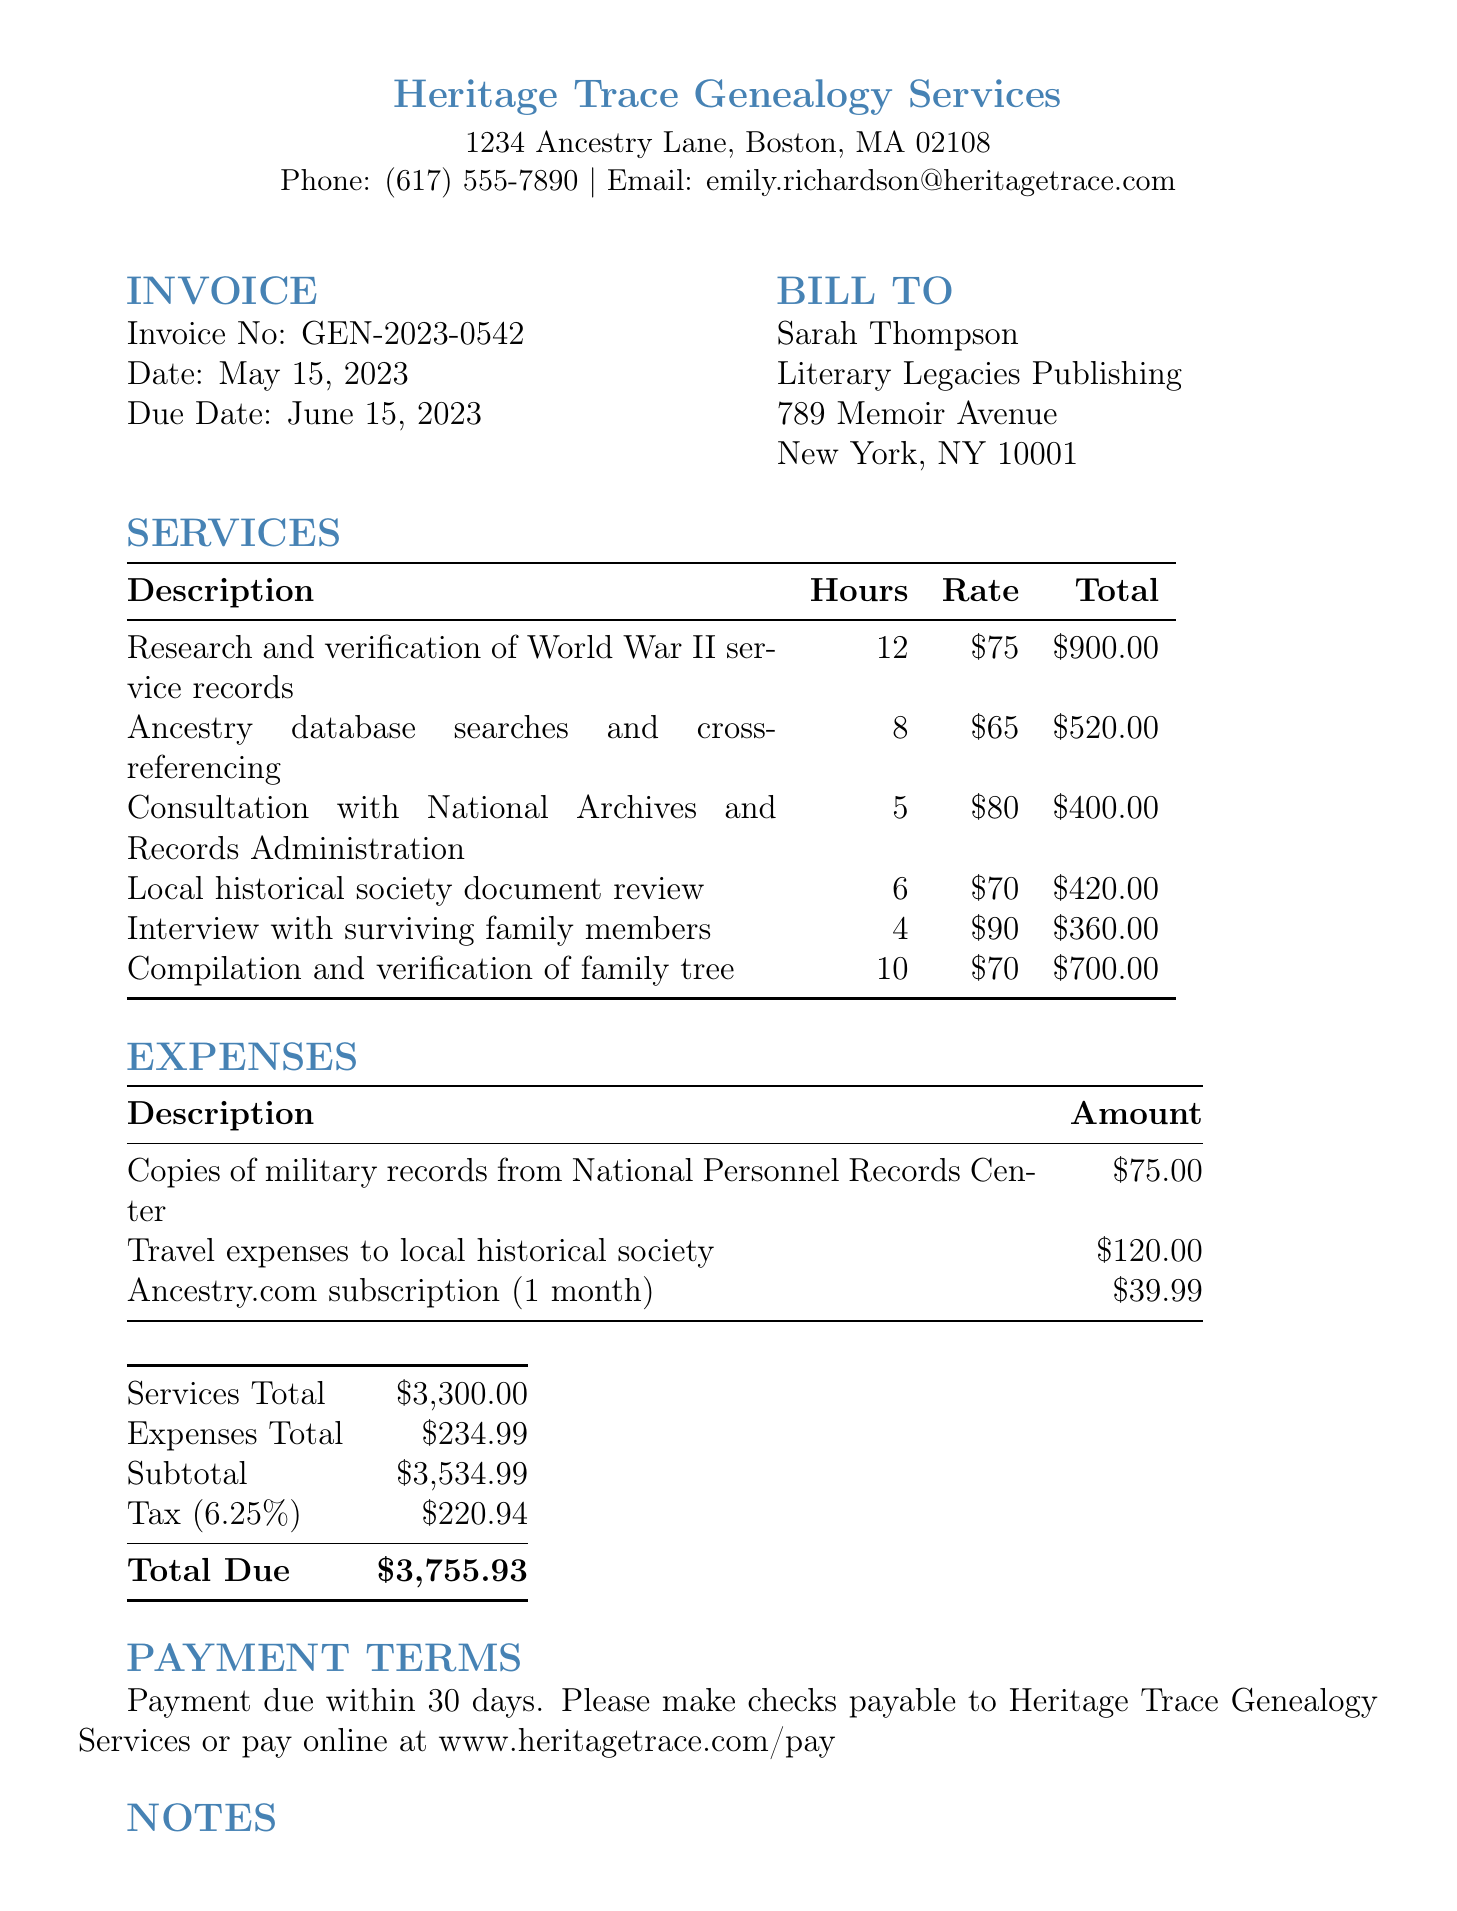What is the invoice number? The invoice number is listed prominently in the document and is GEN-2023-0542.
Answer: GEN-2023-0542 Who is the genealogist? The genealogist's name is provided in the document as Dr. Emily Richardson.
Answer: Dr. Emily Richardson What is the total due amount? The total due amount combines services and expenses totals with tax, resulting in $3755.93.
Answer: $3755.93 How many hours were spent on the consultation with National Archives? The hours for the specific service are provided and are 5 hours for the consultation.
Answer: 5 What is the tax rate applied to the subtotal? The document specifies a tax rate of 6.25% applied to the subtotal.
Answer: 6.25% What is the address of the genealogist's company? The address can be found in the document as 1234 Ancestry Lane, Boston, MA 02108.
Answer: 1234 Ancestry Lane, Boston, MA 02108 What is the description of the first service listed? The first service listed is detailed and described as Research and verification of World War II service records.
Answer: Research and verification of World War II service records When is the payment due? The document states that payment is due within 30 days of the invoice date, specifically by June 15, 2023.
Answer: June 15, 2023 